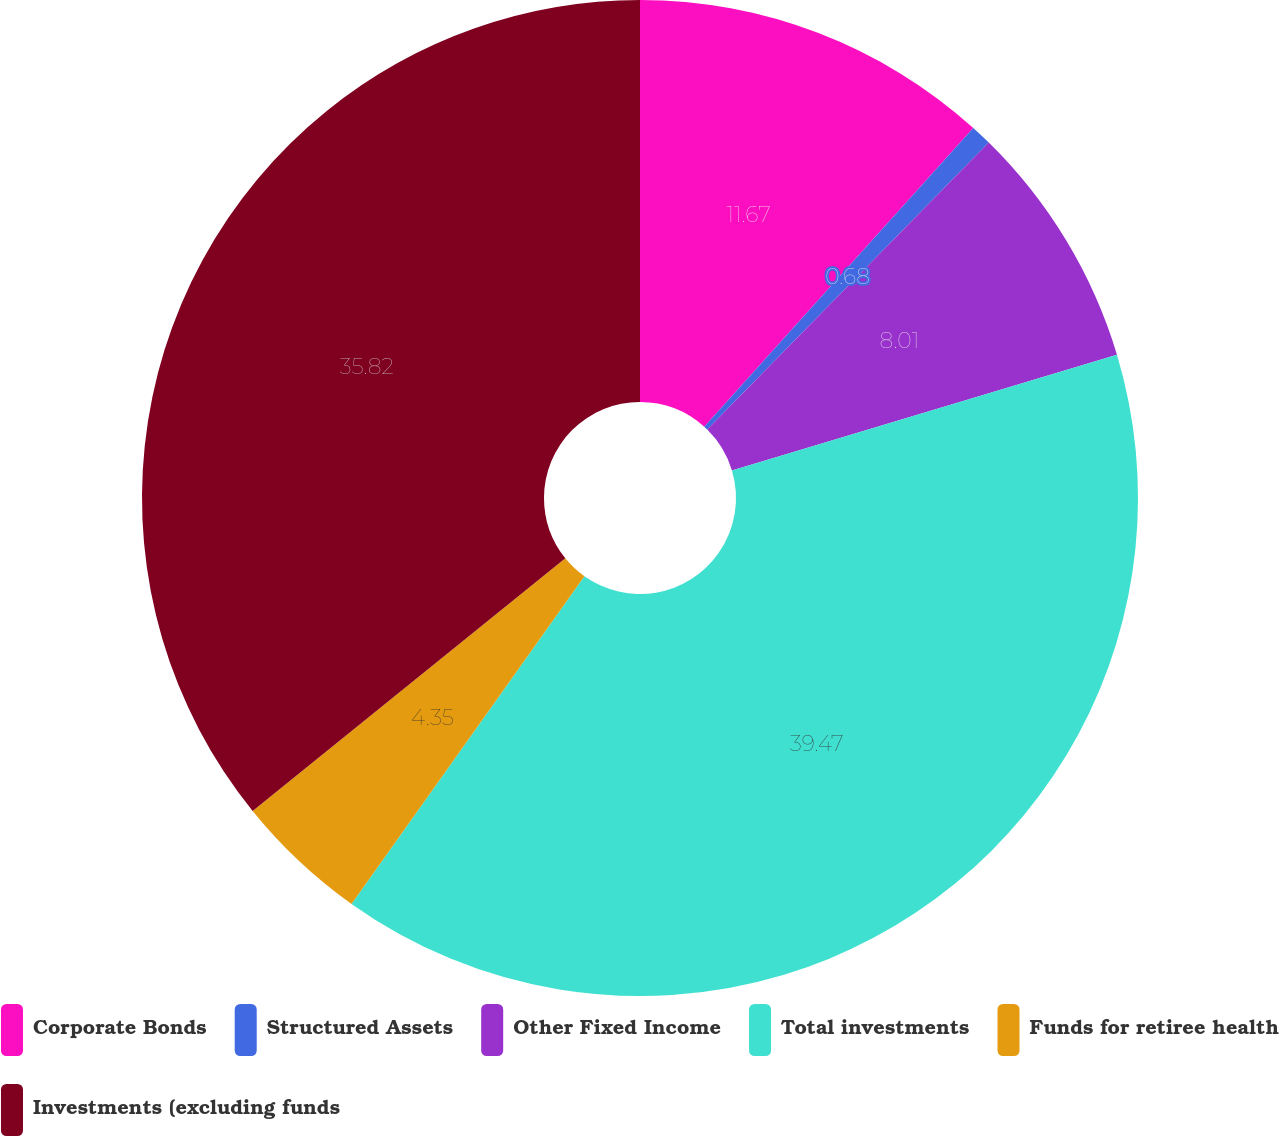<chart> <loc_0><loc_0><loc_500><loc_500><pie_chart><fcel>Corporate Bonds<fcel>Structured Assets<fcel>Other Fixed Income<fcel>Total investments<fcel>Funds for retiree health<fcel>Investments (excluding funds<nl><fcel>11.67%<fcel>0.68%<fcel>8.01%<fcel>39.48%<fcel>4.35%<fcel>35.82%<nl></chart> 